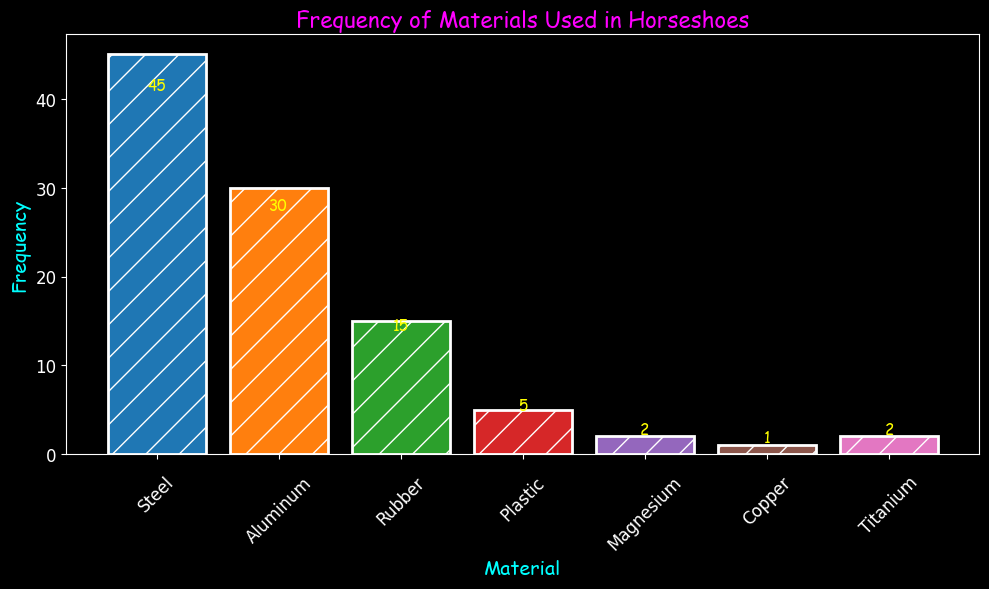What is the most frequently used material for horseshoes? The bar representing Steel reaches the highest point on the chart, indicating it has the highest frequency. By examining the height of the bars, it's clear that Steel appears most frequently, at 45 uses.
Answer: Steel What is the total frequency for Steel and Rubber combined? The frequency of Steel is 45 and the frequency of Rubber is 15. Summing these values, we get 45 + 15 = 60.
Answer: 60 Which material is used least frequently? By visually comparing the heights of the bars, the bar for Copper is the shortest, indicating it has the lowest frequency of use at 1.
Answer: Copper How many more times is Steel used compared to Aluminum? The frequency of Steel is 45 and the frequency of Aluminum is 30. The difference is 45 - 30 = 15.
Answer: 15 Do Plastic and Magnesium have the same frequency? Checking the height of the bars, Plastic has a frequency of 5, while Magnesium has a frequency of 2. Since 5 is not equal to 2, Plastic and Magnesium do not have the same frequency.
Answer: No If you combined the frequency of all materials except Steel, what would the total be? Summing the frequencies of Aluminum (30), Rubber (15), Plastic (5), Magnesium (2), Copper (1), and Titanium (2), the total is 30 + 15 + 5 + 2 + 1 + 2 = 55.
Answer: 55 Which material's bar is colored orange, and what is its frequency? Analyzing the figure, the orange bar represents Aluminum, which has a frequency of 30.
Answer: Aluminum, 30 What is the difference in frequencies between the least used (Copper) and the most used (Steel) materials? The frequency of Steel is 45 and the frequency of Copper is 1. The difference is 45 - 1 = 44.
Answer: 44 Identify the materials that have a frequency less than 10. The materials with frequencies less than 10 are Plastic (5), Magnesium (2), Copper (1), and Titanium (2).
Answer: Plastic, Magnesium, Copper, Titanium If Titanium's frequency doubled, what would the new frequency be, and where would it then rank in the current chart? The current frequency of Titanium is 2. Doubling it gives 2 * 2 = 4. This would make Titanium more frequent than Copper (1) but less than Plastic (5), so it would be the second least used material.
Answer: 4, Second least used 